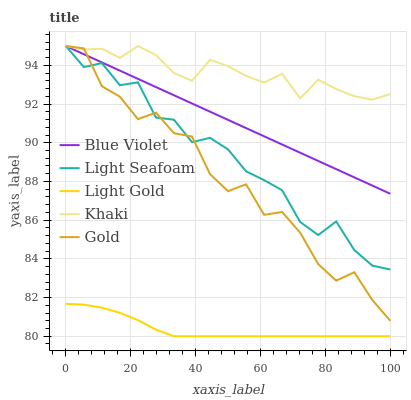Does Light Gold have the minimum area under the curve?
Answer yes or no. Yes. Does Khaki have the maximum area under the curve?
Answer yes or no. Yes. Does Light Seafoam have the minimum area under the curve?
Answer yes or no. No. Does Light Seafoam have the maximum area under the curve?
Answer yes or no. No. Is Blue Violet the smoothest?
Answer yes or no. Yes. Is Gold the roughest?
Answer yes or no. Yes. Is Light Seafoam the smoothest?
Answer yes or no. No. Is Light Seafoam the roughest?
Answer yes or no. No. Does Light Gold have the lowest value?
Answer yes or no. Yes. Does Light Seafoam have the lowest value?
Answer yes or no. No. Does Blue Violet have the highest value?
Answer yes or no. Yes. Does Light Gold have the highest value?
Answer yes or no. No. Is Light Gold less than Gold?
Answer yes or no. Yes. Is Blue Violet greater than Light Gold?
Answer yes or no. Yes. Does Gold intersect Khaki?
Answer yes or no. Yes. Is Gold less than Khaki?
Answer yes or no. No. Is Gold greater than Khaki?
Answer yes or no. No. Does Light Gold intersect Gold?
Answer yes or no. No. 